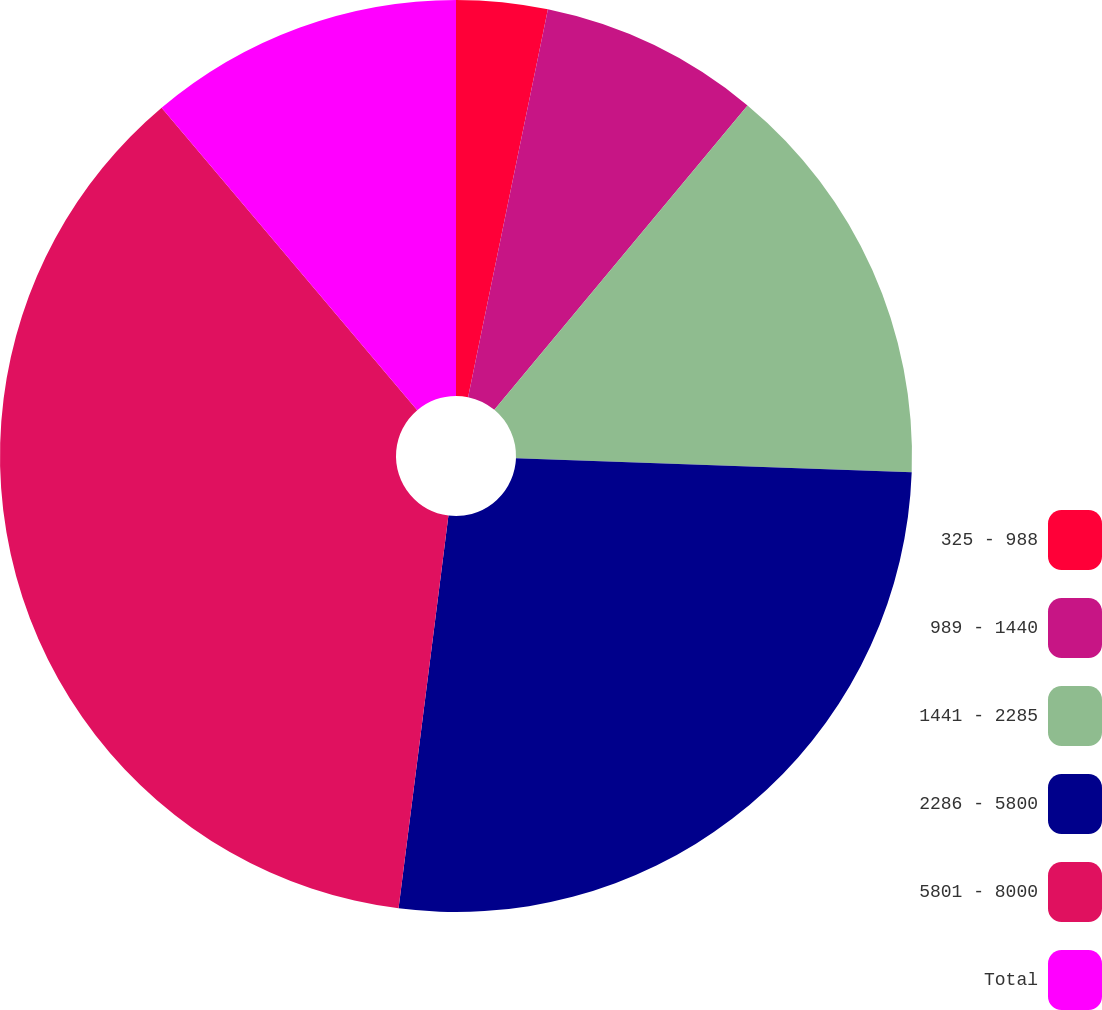Convert chart. <chart><loc_0><loc_0><loc_500><loc_500><pie_chart><fcel>325 - 988<fcel>989 - 1440<fcel>1441 - 2285<fcel>2286 - 5800<fcel>5801 - 8000<fcel>Total<nl><fcel>3.23%<fcel>7.81%<fcel>14.53%<fcel>26.44%<fcel>36.82%<fcel>11.17%<nl></chart> 